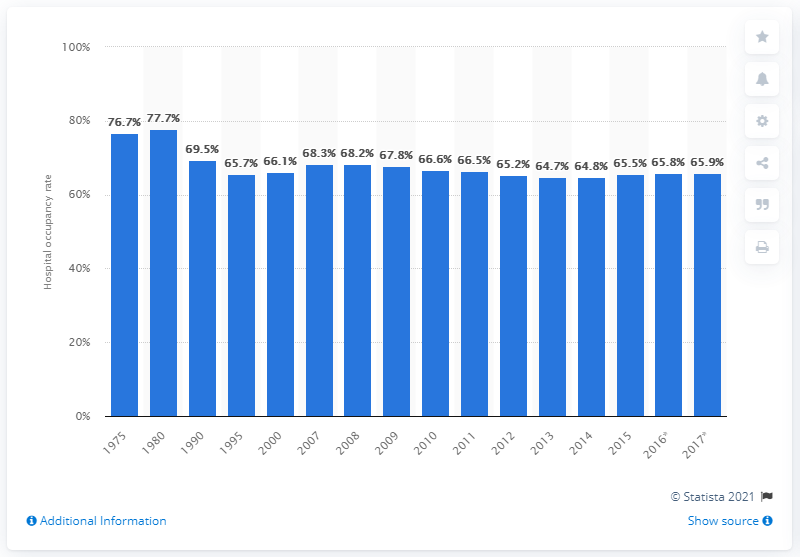Mention a couple of crucial points in this snapshot. In 2017, the occupancy rate of hospitals in the United States was 65.9%. 